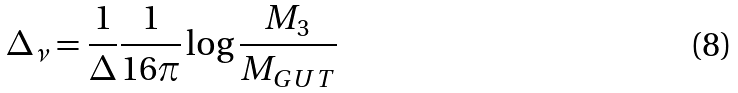<formula> <loc_0><loc_0><loc_500><loc_500>\Delta _ { \nu } = \frac { 1 } { \Delta } \frac { 1 } { 1 6 \pi } \log { \frac { M _ { 3 } } { M _ { G U T } } }</formula> 